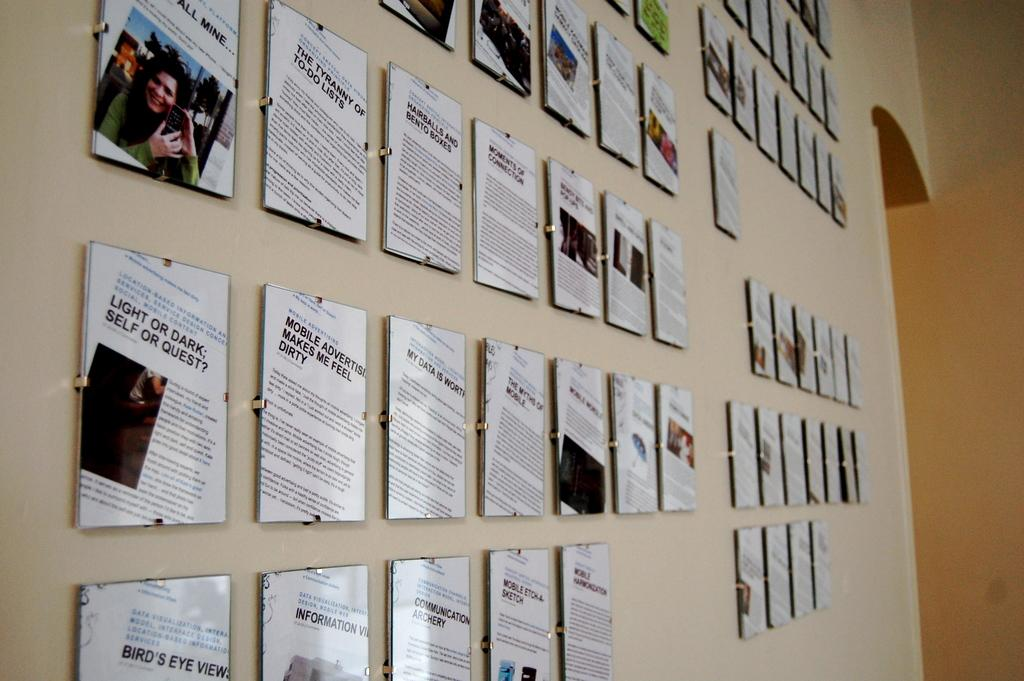<image>
Create a compact narrative representing the image presented. Several articles are displayed on a wall with one reading, Light or dark; Self or Quest? located in the second row from bottom. 